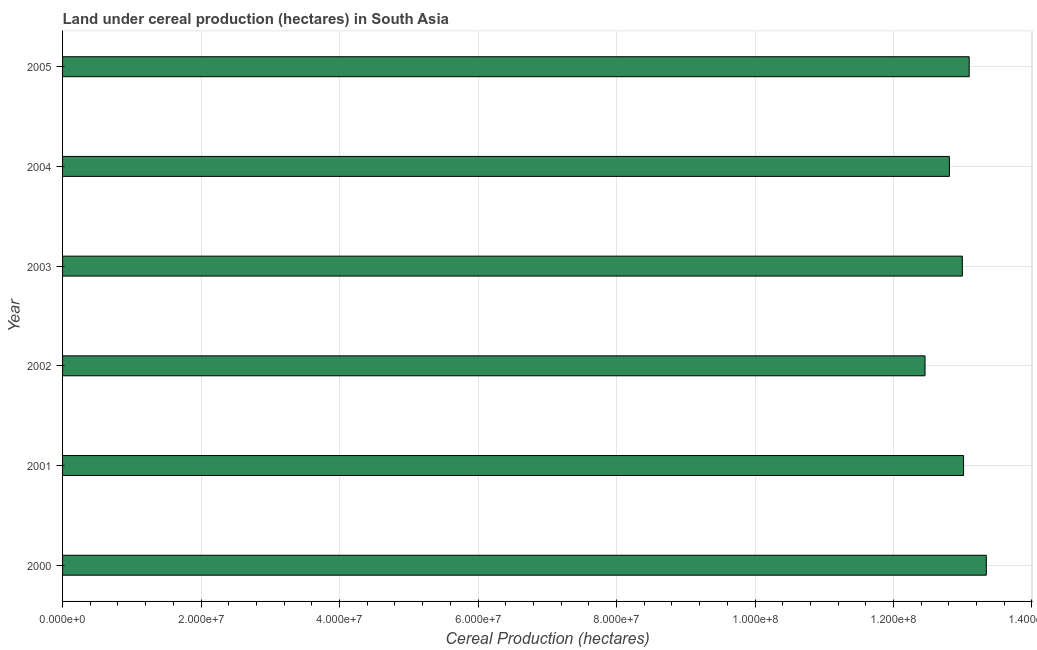Does the graph contain grids?
Give a very brief answer. Yes. What is the title of the graph?
Your response must be concise. Land under cereal production (hectares) in South Asia. What is the label or title of the X-axis?
Ensure brevity in your answer.  Cereal Production (hectares). What is the land under cereal production in 2004?
Offer a very short reply. 1.28e+08. Across all years, what is the maximum land under cereal production?
Keep it short and to the point. 1.33e+08. Across all years, what is the minimum land under cereal production?
Offer a terse response. 1.25e+08. In which year was the land under cereal production maximum?
Offer a terse response. 2000. In which year was the land under cereal production minimum?
Your response must be concise. 2002. What is the sum of the land under cereal production?
Make the answer very short. 7.77e+08. What is the difference between the land under cereal production in 2002 and 2004?
Keep it short and to the point. -3.52e+06. What is the average land under cereal production per year?
Make the answer very short. 1.30e+08. What is the median land under cereal production?
Your answer should be very brief. 1.30e+08. Do a majority of the years between 2001 and 2005 (inclusive) have land under cereal production greater than 116000000 hectares?
Give a very brief answer. Yes. What is the ratio of the land under cereal production in 2001 to that in 2004?
Offer a very short reply. 1.02. What is the difference between the highest and the second highest land under cereal production?
Provide a succinct answer. 2.47e+06. What is the difference between the highest and the lowest land under cereal production?
Your answer should be compact. 8.85e+06. In how many years, is the land under cereal production greater than the average land under cereal production taken over all years?
Ensure brevity in your answer.  4. How many bars are there?
Provide a short and direct response. 6. Are all the bars in the graph horizontal?
Provide a succinct answer. Yes. How many years are there in the graph?
Keep it short and to the point. 6. Are the values on the major ticks of X-axis written in scientific E-notation?
Offer a terse response. Yes. What is the Cereal Production (hectares) of 2000?
Provide a succinct answer. 1.33e+08. What is the Cereal Production (hectares) of 2001?
Give a very brief answer. 1.30e+08. What is the Cereal Production (hectares) in 2002?
Give a very brief answer. 1.25e+08. What is the Cereal Production (hectares) in 2003?
Provide a succinct answer. 1.30e+08. What is the Cereal Production (hectares) of 2004?
Offer a very short reply. 1.28e+08. What is the Cereal Production (hectares) of 2005?
Offer a terse response. 1.31e+08. What is the difference between the Cereal Production (hectares) in 2000 and 2001?
Offer a terse response. 3.28e+06. What is the difference between the Cereal Production (hectares) in 2000 and 2002?
Your answer should be very brief. 8.85e+06. What is the difference between the Cereal Production (hectares) in 2000 and 2003?
Keep it short and to the point. 3.46e+06. What is the difference between the Cereal Production (hectares) in 2000 and 2004?
Keep it short and to the point. 5.33e+06. What is the difference between the Cereal Production (hectares) in 2000 and 2005?
Provide a succinct answer. 2.47e+06. What is the difference between the Cereal Production (hectares) in 2001 and 2002?
Your answer should be compact. 5.57e+06. What is the difference between the Cereal Production (hectares) in 2001 and 2003?
Your answer should be very brief. 1.79e+05. What is the difference between the Cereal Production (hectares) in 2001 and 2004?
Offer a terse response. 2.05e+06. What is the difference between the Cereal Production (hectares) in 2001 and 2005?
Provide a succinct answer. -8.09e+05. What is the difference between the Cereal Production (hectares) in 2002 and 2003?
Give a very brief answer. -5.39e+06. What is the difference between the Cereal Production (hectares) in 2002 and 2004?
Offer a very short reply. -3.52e+06. What is the difference between the Cereal Production (hectares) in 2002 and 2005?
Keep it short and to the point. -6.38e+06. What is the difference between the Cereal Production (hectares) in 2003 and 2004?
Ensure brevity in your answer.  1.87e+06. What is the difference between the Cereal Production (hectares) in 2003 and 2005?
Give a very brief answer. -9.89e+05. What is the difference between the Cereal Production (hectares) in 2004 and 2005?
Offer a very short reply. -2.86e+06. What is the ratio of the Cereal Production (hectares) in 2000 to that in 2002?
Your answer should be very brief. 1.07. What is the ratio of the Cereal Production (hectares) in 2000 to that in 2004?
Keep it short and to the point. 1.04. What is the ratio of the Cereal Production (hectares) in 2000 to that in 2005?
Your response must be concise. 1.02. What is the ratio of the Cereal Production (hectares) in 2001 to that in 2002?
Keep it short and to the point. 1.04. What is the ratio of the Cereal Production (hectares) in 2001 to that in 2003?
Your answer should be very brief. 1. What is the ratio of the Cereal Production (hectares) in 2001 to that in 2004?
Your response must be concise. 1.02. What is the ratio of the Cereal Production (hectares) in 2002 to that in 2005?
Make the answer very short. 0.95. What is the ratio of the Cereal Production (hectares) in 2003 to that in 2005?
Give a very brief answer. 0.99. 